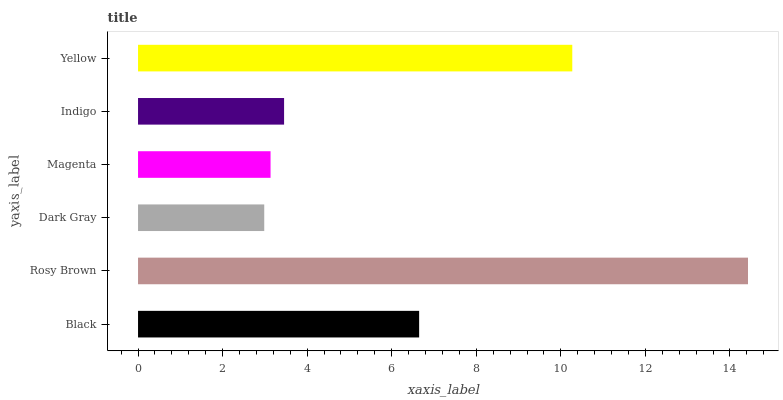Is Dark Gray the minimum?
Answer yes or no. Yes. Is Rosy Brown the maximum?
Answer yes or no. Yes. Is Rosy Brown the minimum?
Answer yes or no. No. Is Dark Gray the maximum?
Answer yes or no. No. Is Rosy Brown greater than Dark Gray?
Answer yes or no. Yes. Is Dark Gray less than Rosy Brown?
Answer yes or no. Yes. Is Dark Gray greater than Rosy Brown?
Answer yes or no. No. Is Rosy Brown less than Dark Gray?
Answer yes or no. No. Is Black the high median?
Answer yes or no. Yes. Is Indigo the low median?
Answer yes or no. Yes. Is Magenta the high median?
Answer yes or no. No. Is Yellow the low median?
Answer yes or no. No. 